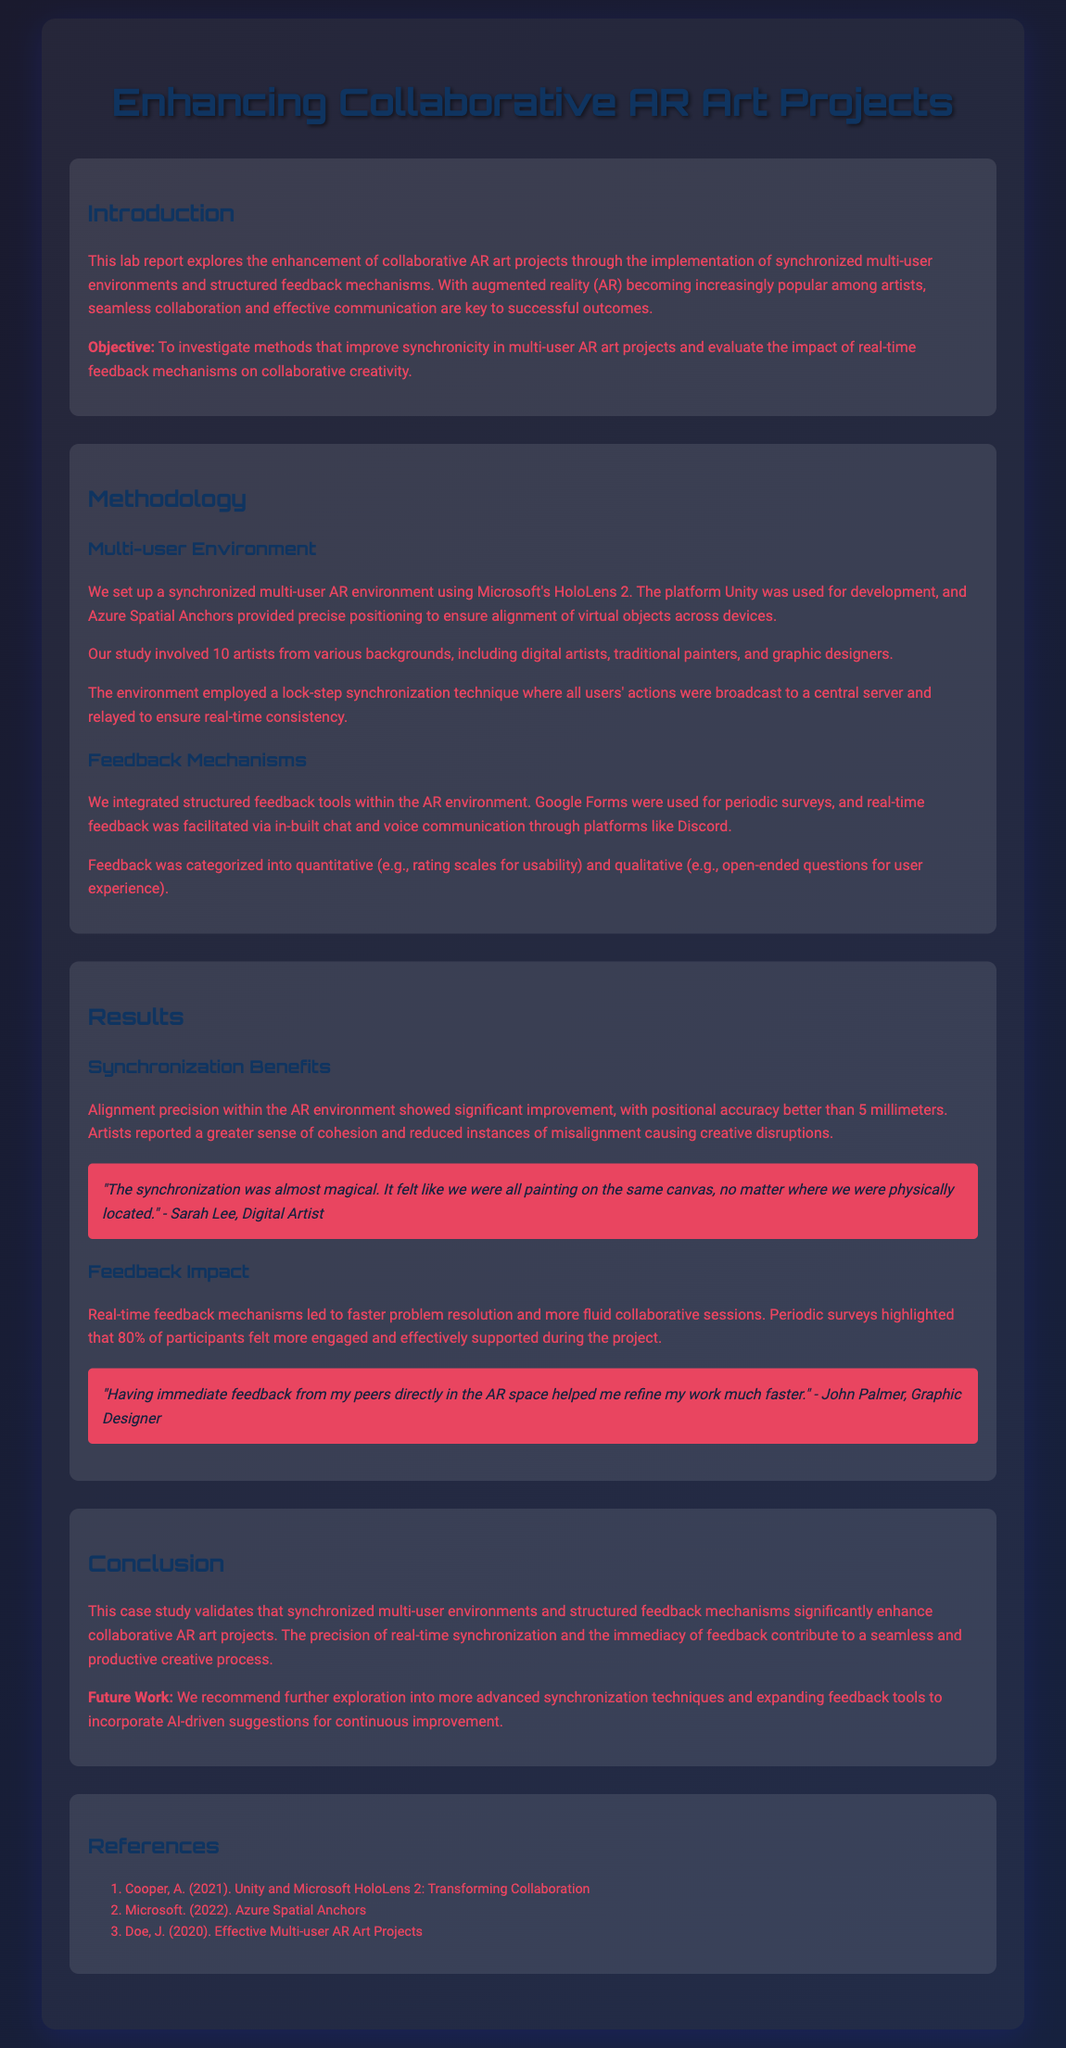What was the objective of the report? The objective of the report is to investigate methods that improve synchronicity in multi-user AR art projects and evaluate the impact of real-time feedback mechanisms on collaborative creativity.
Answer: To investigate methods that improve synchronicity in multi-user AR art projects and evaluate the impact of real-time feedback mechanisms on collaborative creativity How many artists participated in the study? The number of artists involved in the study is mentioned in the Methodology section.
Answer: 10 artists What technology was used for synchronized multi-user environments? The specific technology used for creating the multi-user environment is stated in the Methodology section.
Answer: Microsoft's HoloLens 2 What percentage of participants felt more engaged due to real-time feedback? The percentage is found in the Results section and highlights participant engagement.
Answer: 80% What technique ensured real-time consistency among users? The technique to ensure consistency in a multi-user environment is described in the Methodology section.
Answer: Lock-step synchronization What is the positional accuracy achieved in the AR environment? The positional accuracy achieved during the project is mentioned in the Results section.
Answer: Better than 5 millimeters What feedback tool was used for periodic surveys? The tool for periodic surveys is indicated in the Methodology section.
Answer: Google Forms What recommendation is made for future work? The recommendation for future work focuses on improvements and is stated in the Conclusion section.
Answer: Explore more advanced synchronization techniques and expand feedback tools to incorporate AI-driven suggestions 